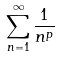Convert formula to latex. <formula><loc_0><loc_0><loc_500><loc_500>\sum _ { n = 1 } ^ { \infty } \frac { 1 } { n ^ { p } }</formula> 